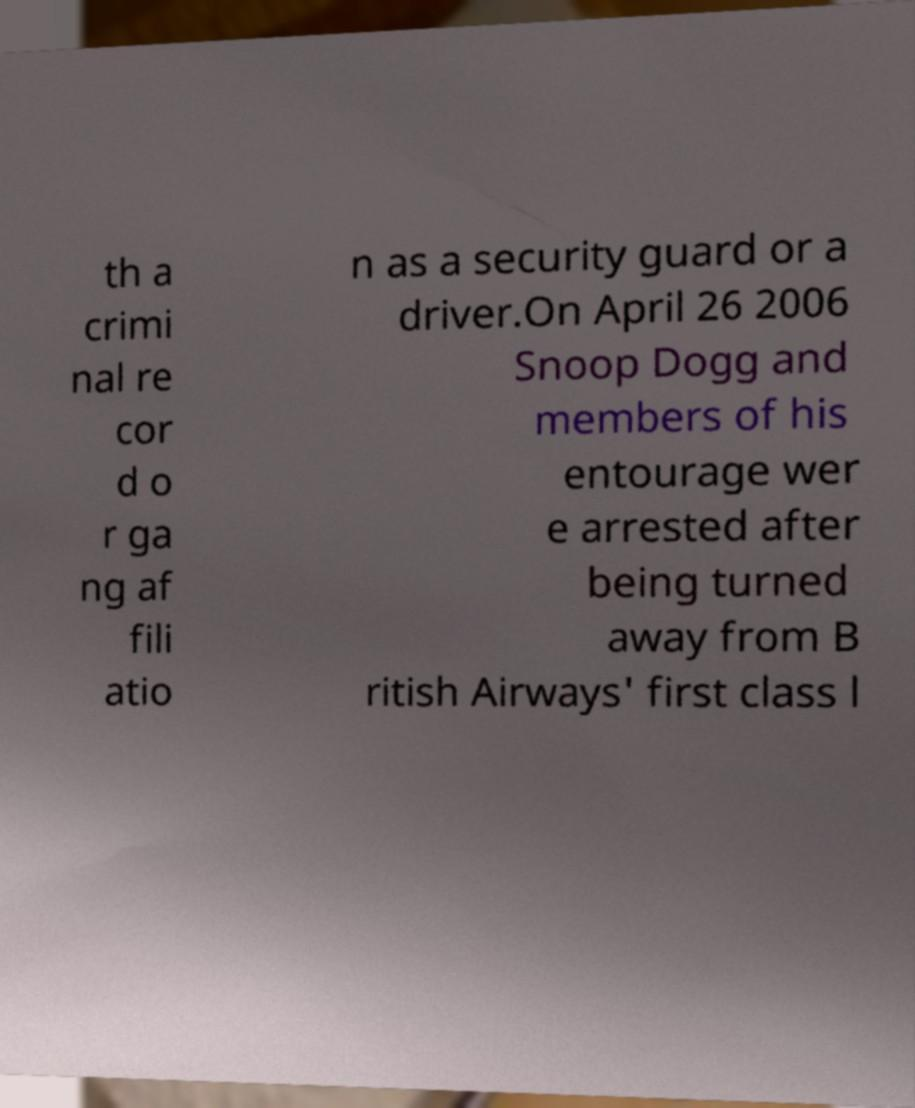I need the written content from this picture converted into text. Can you do that? th a crimi nal re cor d o r ga ng af fili atio n as a security guard or a driver.On April 26 2006 Snoop Dogg and members of his entourage wer e arrested after being turned away from B ritish Airways' first class l 